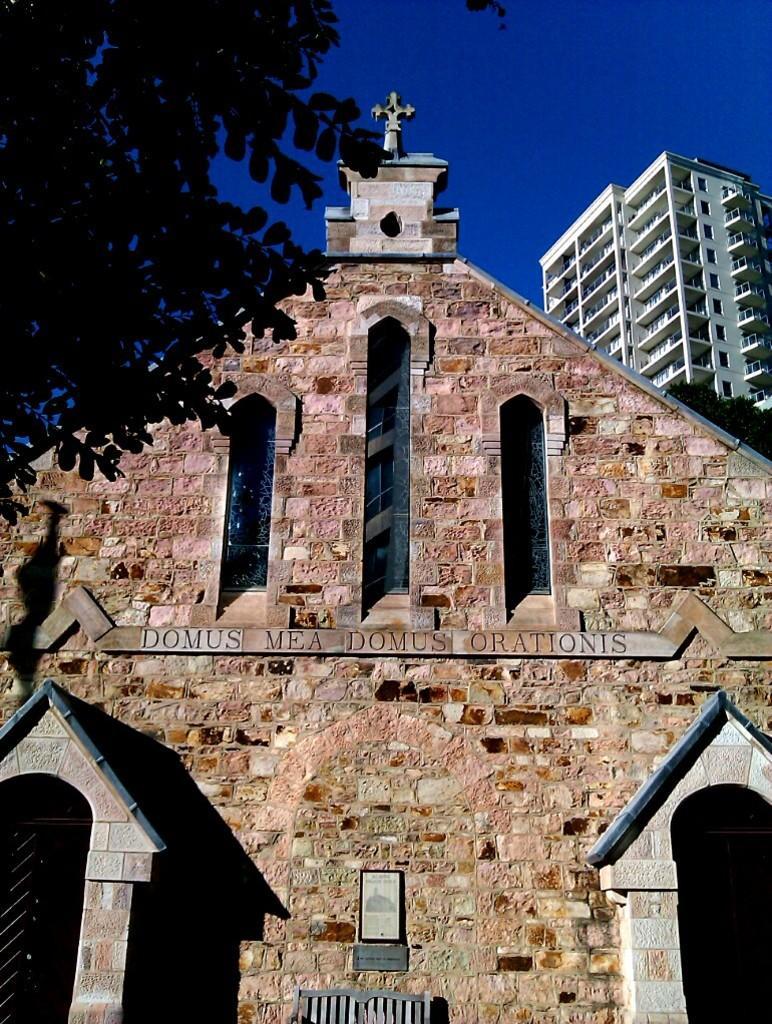Describe this image in one or two sentences. In this image, we can see buildings. There is a branch in the top left of the image. There is a sky at the top of the image. 